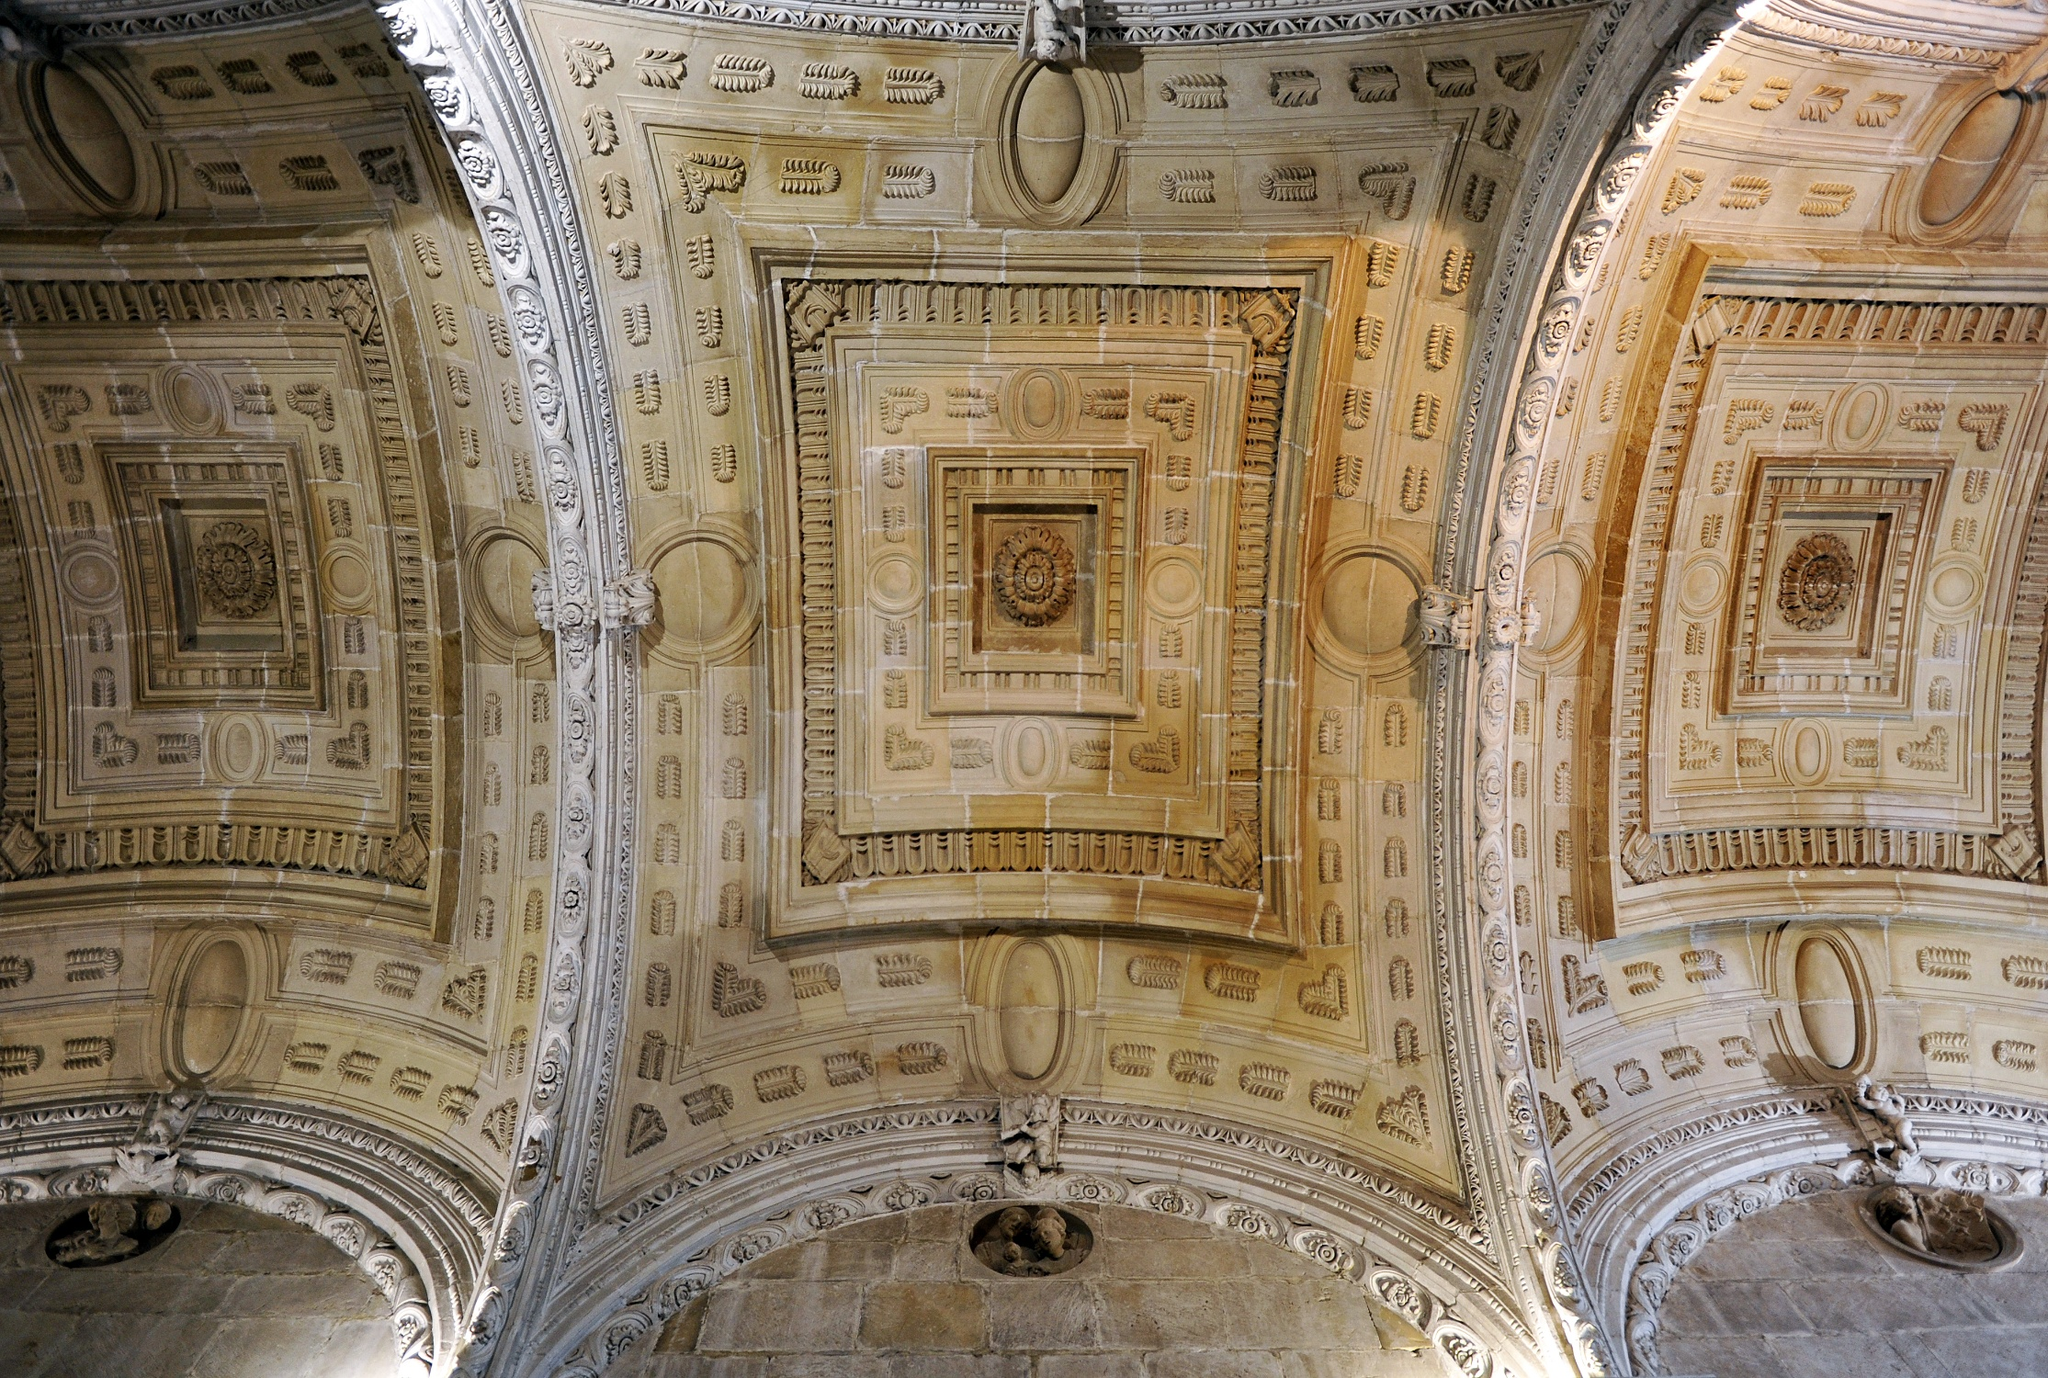How would you feel standing right underneath that ceiling? Standing underneath that ceiling would likely evoke a sense of awe and admiration. The grandeur and intricate details are a testament to the craftsmanship and artistic vision of its creators. The sheer scale and beauty of the ceiling might make one feel small yet connected to the vast history and cultural significance it represents. It would be a humbling experience, filling one with a deep appreciation for the artistry and dedication that went into its creation. 